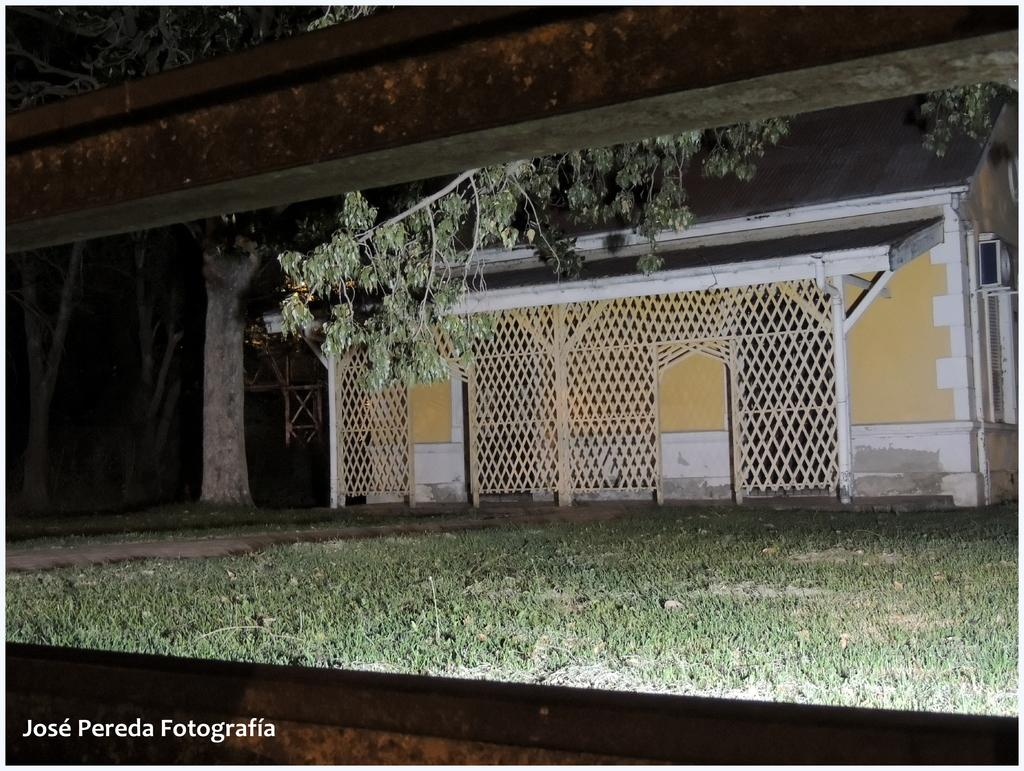What is the main structure in the center of the image? There is a house and a shed in the center of the image. What else can be seen in the center of the image? There is a mesh and trees in the center of the image. What is visible at the bottom of the image? The ground is visible at the bottom of the image, and there is text visible there as well. What type of thought is being expressed by the knot in the image? There is no knot present in the image, and therefore no thoughts can be attributed to it. 